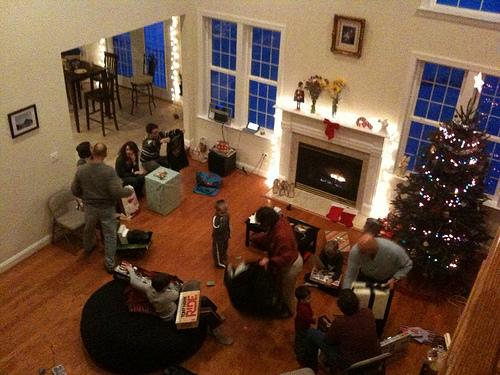What can often be found under the tree seen here?

Choices:
A) mice
B) elves
C) dogs
D) gifts gifts 